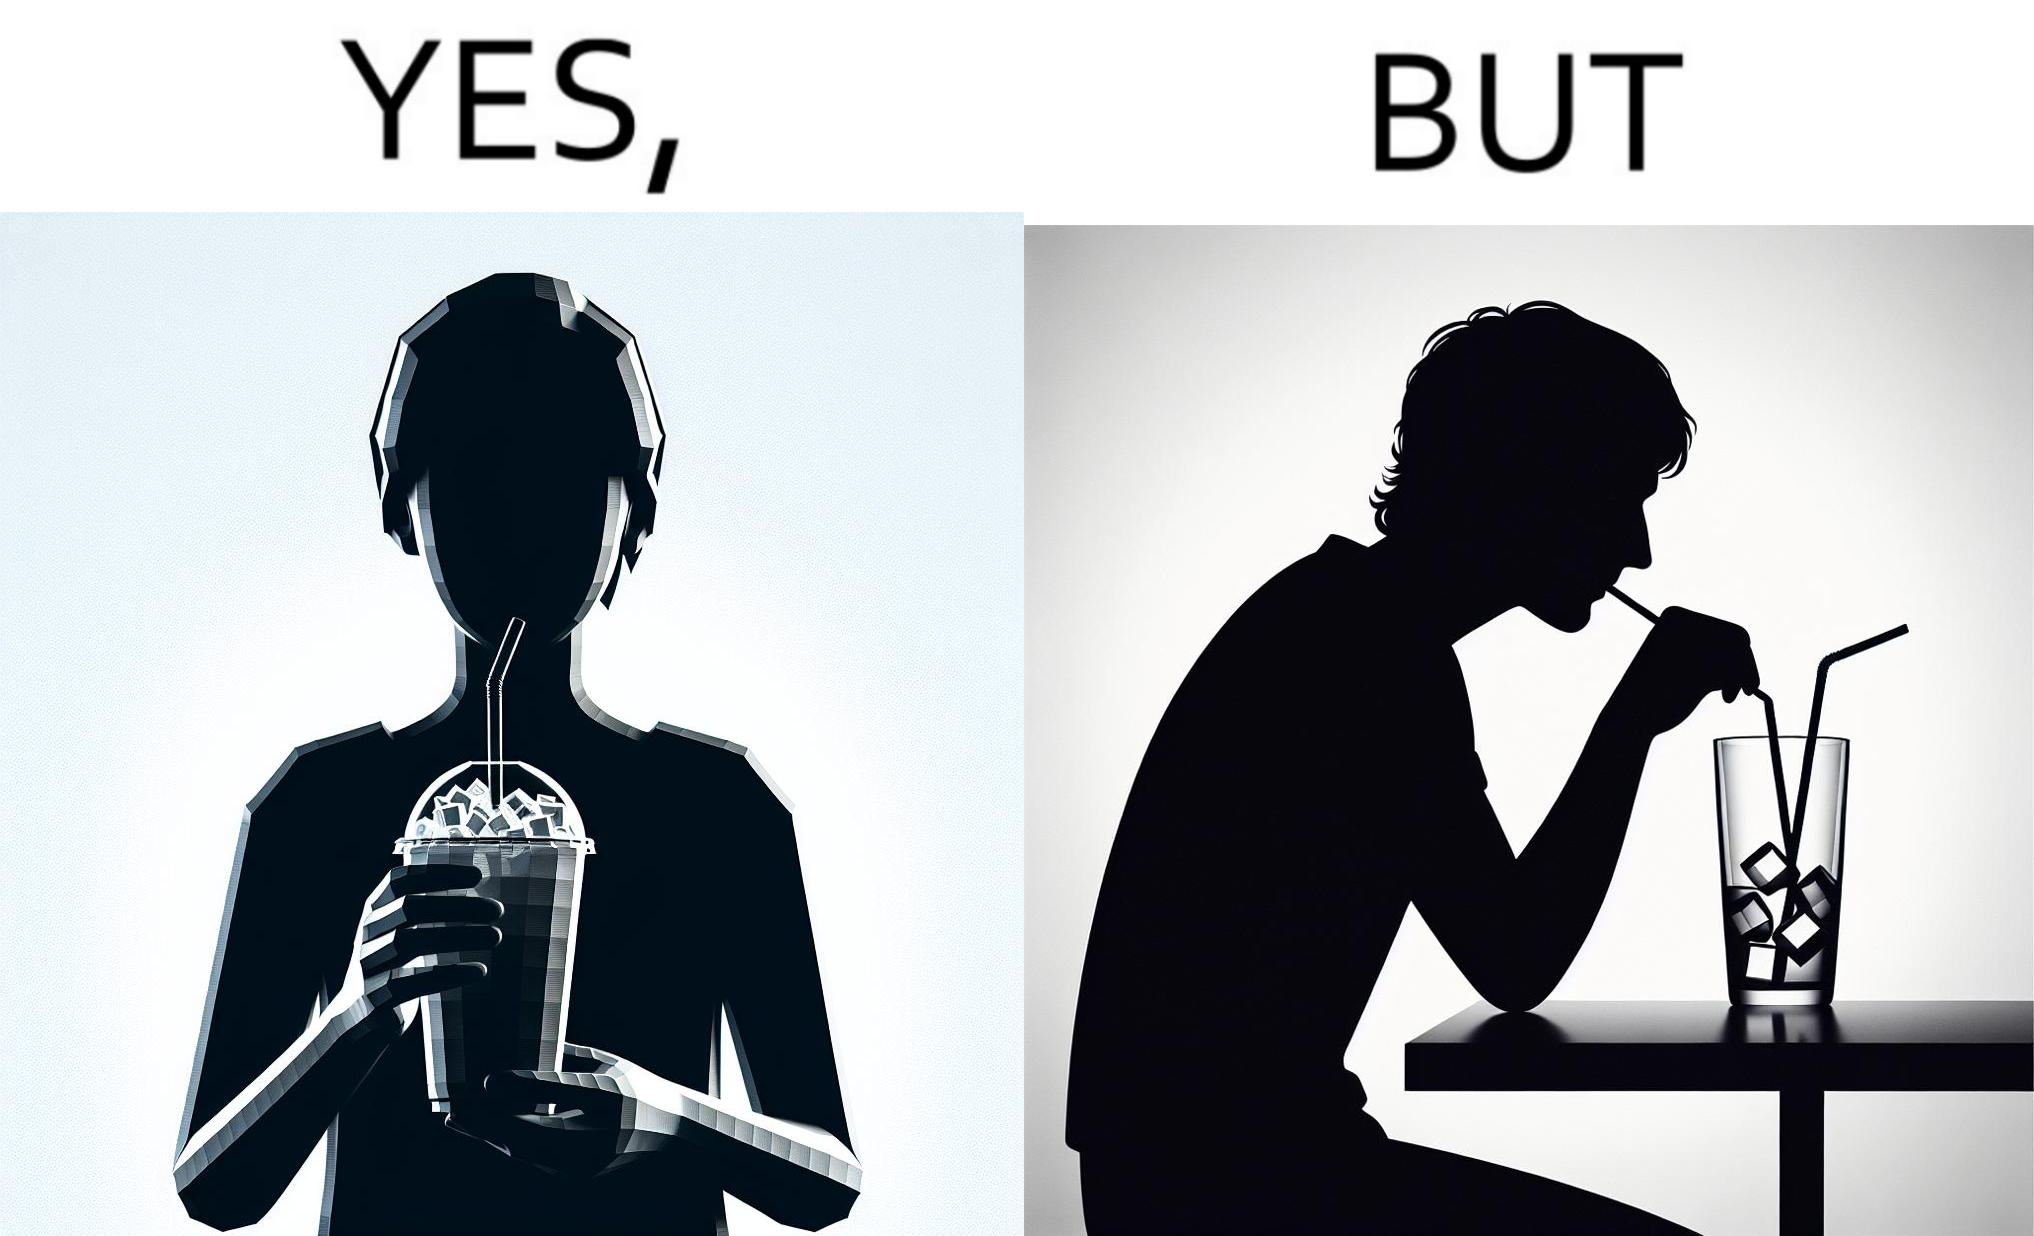Would you classify this image as satirical? Yes, this image is satirical. 